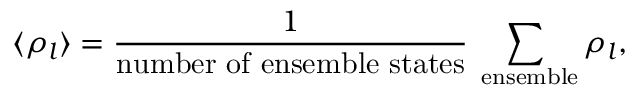<formula> <loc_0><loc_0><loc_500><loc_500>\langle \rho _ { l } \rangle = \frac { 1 } { n u m b e r o f e n s e m b l e s t a t e s } \sum _ { e n s e m b l e } \rho _ { l } ,</formula> 